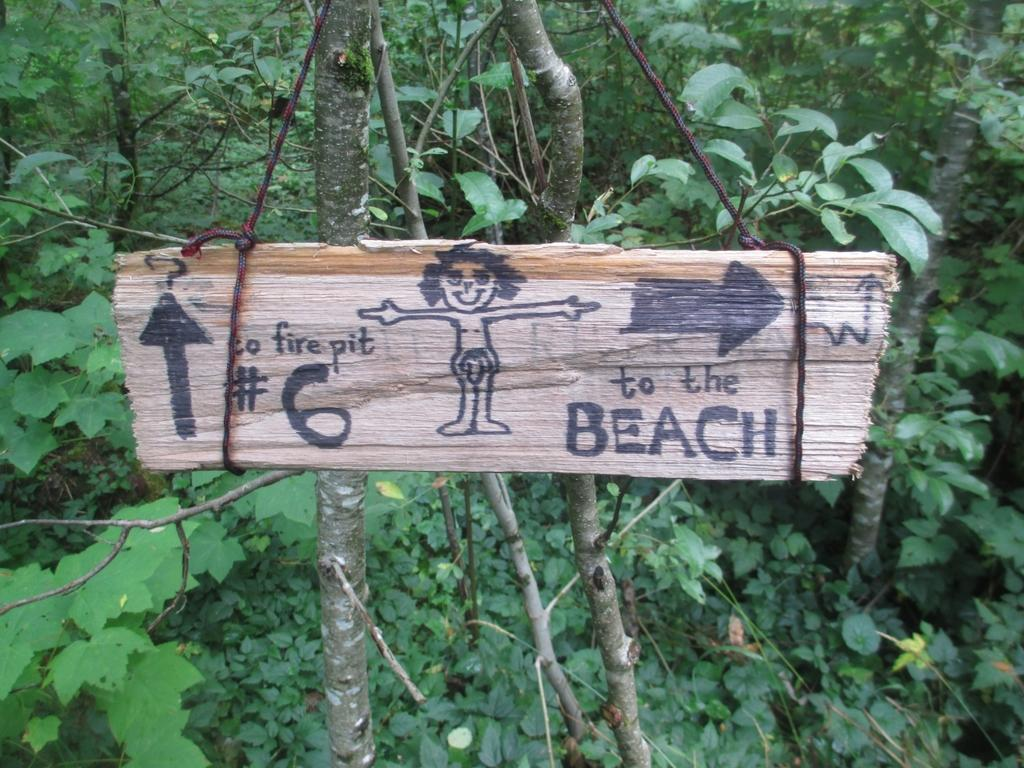What is the main object in the image? There is a wooden plank in the image. What is done to the wooden plank? Drawings are done on the wooden plank. How is the wooden plank positioned? The wooden plank is hanged on a tree. What can be seen in the background of the image? There are many trees visible in the background of the image. What type of rice is being cooked on the stove in the image? There is no rice or stove present in the image; it features a wooden plank with drawings hung on a tree. How many babies are visible in the image? There are no babies present in the image. 